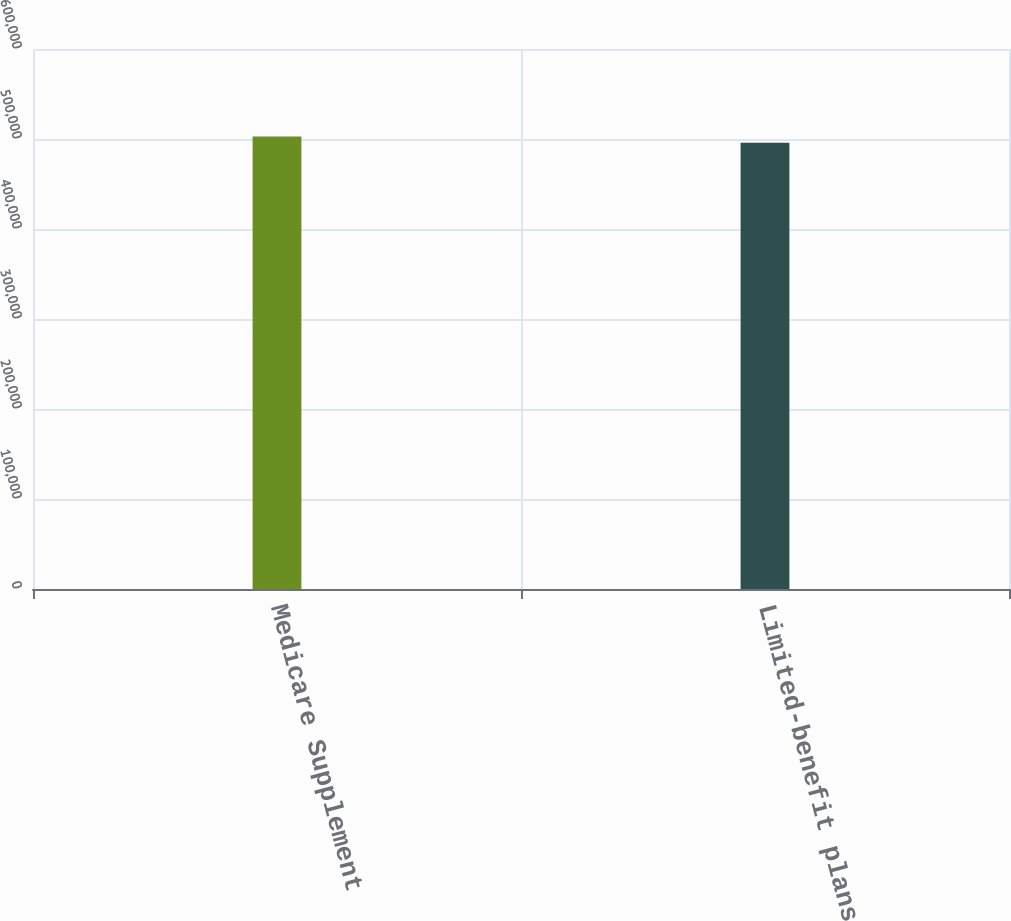Convert chart. <chart><loc_0><loc_0><loc_500><loc_500><bar_chart><fcel>Medicare Supplement<fcel>Limited-benefit plans<nl><fcel>502691<fcel>495943<nl></chart> 